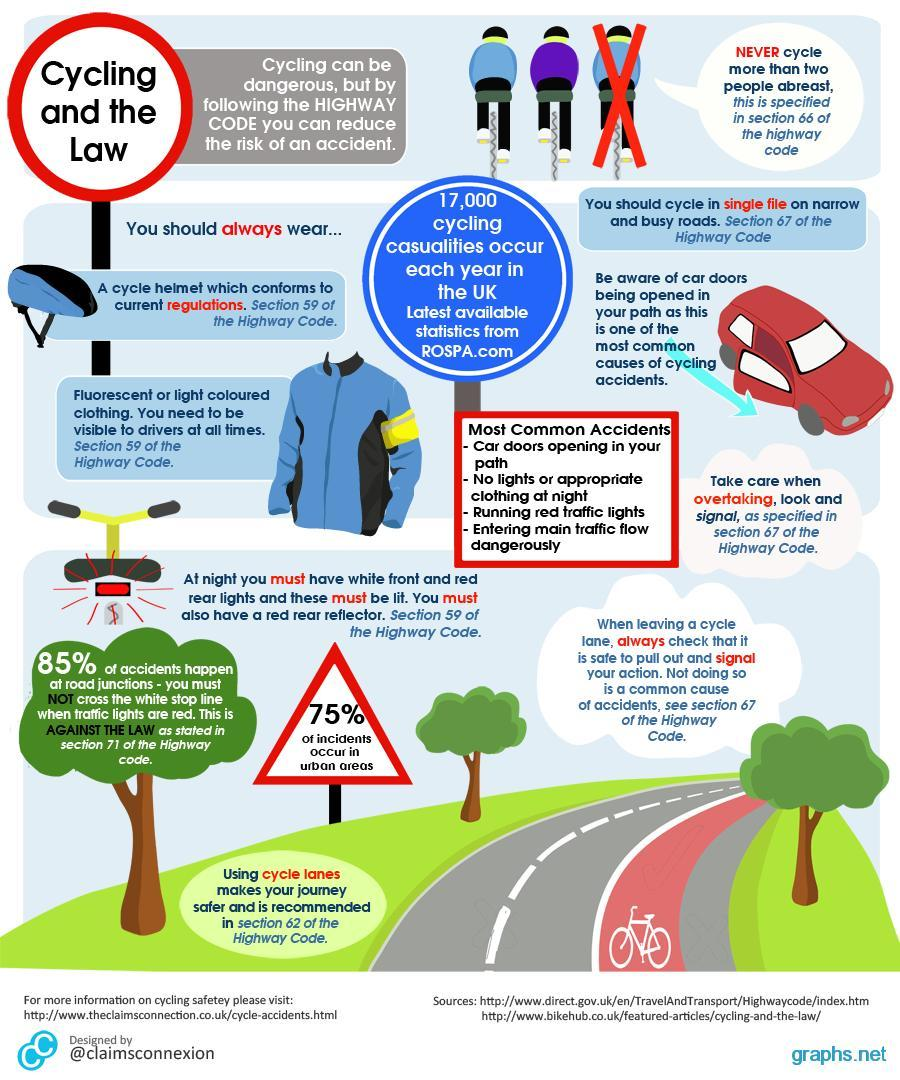How many trees are in this infographic?
Answer the question with a short phrase. 3 What is the color of the car-blue, yellow, red, or green? red How many points are under the heading most common accidents? 4 What percentage of accidents occur in other parts of the road? 15% What percentage of accidents occur not in urban areas? 25% 